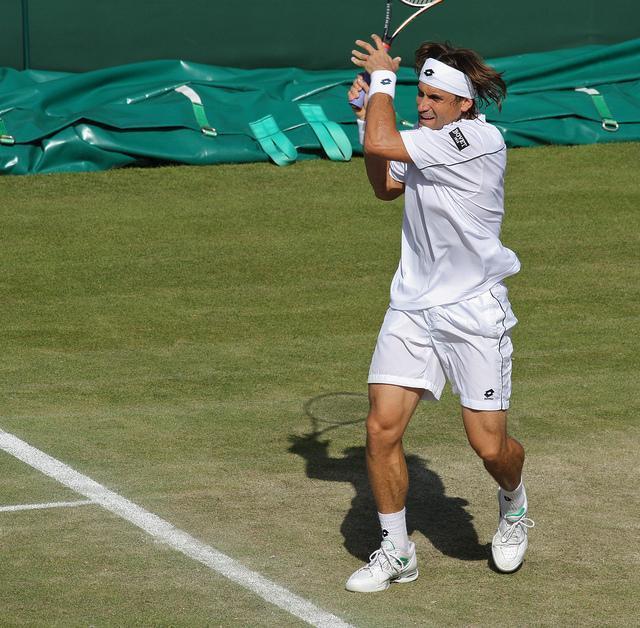How many elephants are standing on two legs?
Give a very brief answer. 0. 